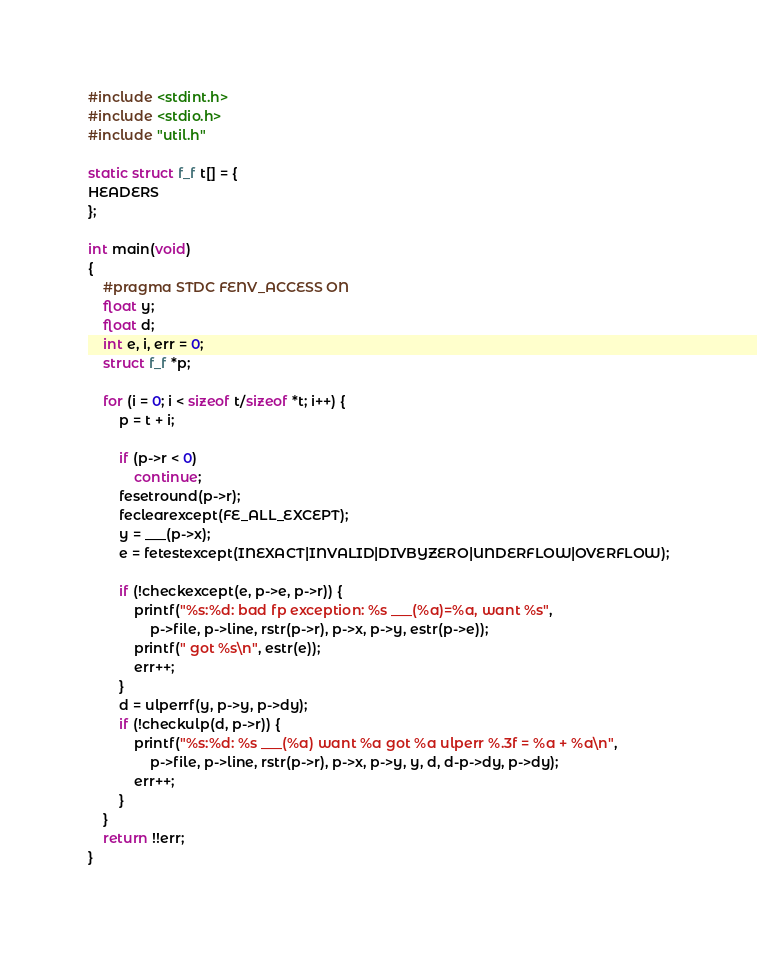Convert code to text. <code><loc_0><loc_0><loc_500><loc_500><_C_>#include <stdint.h>
#include <stdio.h>
#include "util.h"

static struct f_f t[] = {
HEADERS
};

int main(void)
{
	#pragma STDC FENV_ACCESS ON
	float y;
	float d;
	int e, i, err = 0;
	struct f_f *p;

	for (i = 0; i < sizeof t/sizeof *t; i++) {
		p = t + i;

		if (p->r < 0)
			continue;
		fesetround(p->r);
		feclearexcept(FE_ALL_EXCEPT);
		y = ___(p->x);
		e = fetestexcept(INEXACT|INVALID|DIVBYZERO|UNDERFLOW|OVERFLOW);

		if (!checkexcept(e, p->e, p->r)) {
			printf("%s:%d: bad fp exception: %s ___(%a)=%a, want %s",
				p->file, p->line, rstr(p->r), p->x, p->y, estr(p->e));
			printf(" got %s\n", estr(e));
			err++;
		}
		d = ulperrf(y, p->y, p->dy);
		if (!checkulp(d, p->r)) {
			printf("%s:%d: %s ___(%a) want %a got %a ulperr %.3f = %a + %a\n",
				p->file, p->line, rstr(p->r), p->x, p->y, y, d, d-p->dy, p->dy);
			err++;
		}
	}
	return !!err;
}
</code> 